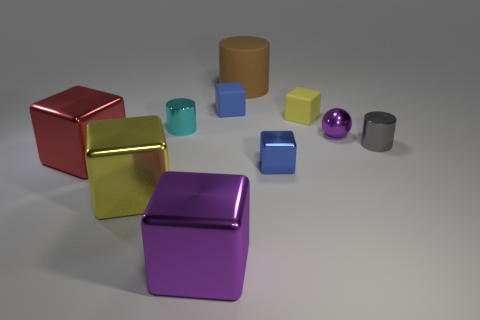Subtract 2 cubes. How many cubes are left? 4 Subtract all purple cubes. How many cubes are left? 5 Subtract all purple metal cubes. How many cubes are left? 5 Subtract all brown blocks. Subtract all cyan spheres. How many blocks are left? 6 Subtract all cylinders. How many objects are left? 7 Subtract all small things. Subtract all brown things. How many objects are left? 3 Add 4 gray cylinders. How many gray cylinders are left? 5 Add 8 purple metallic spheres. How many purple metallic spheres exist? 9 Subtract 0 red balls. How many objects are left? 10 